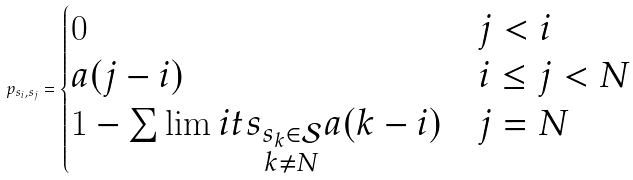<formula> <loc_0><loc_0><loc_500><loc_500>p _ { s _ { i } , s _ { j } } = \begin{cases} 0 & j < i \\ a ( j - i ) & i \leq j < N \\ 1 - \sum \lim i t s _ { \substack { s _ { k } \in \mathcal { S } \\ k \ne N } } a ( k - i ) & j = N \end{cases}</formula> 